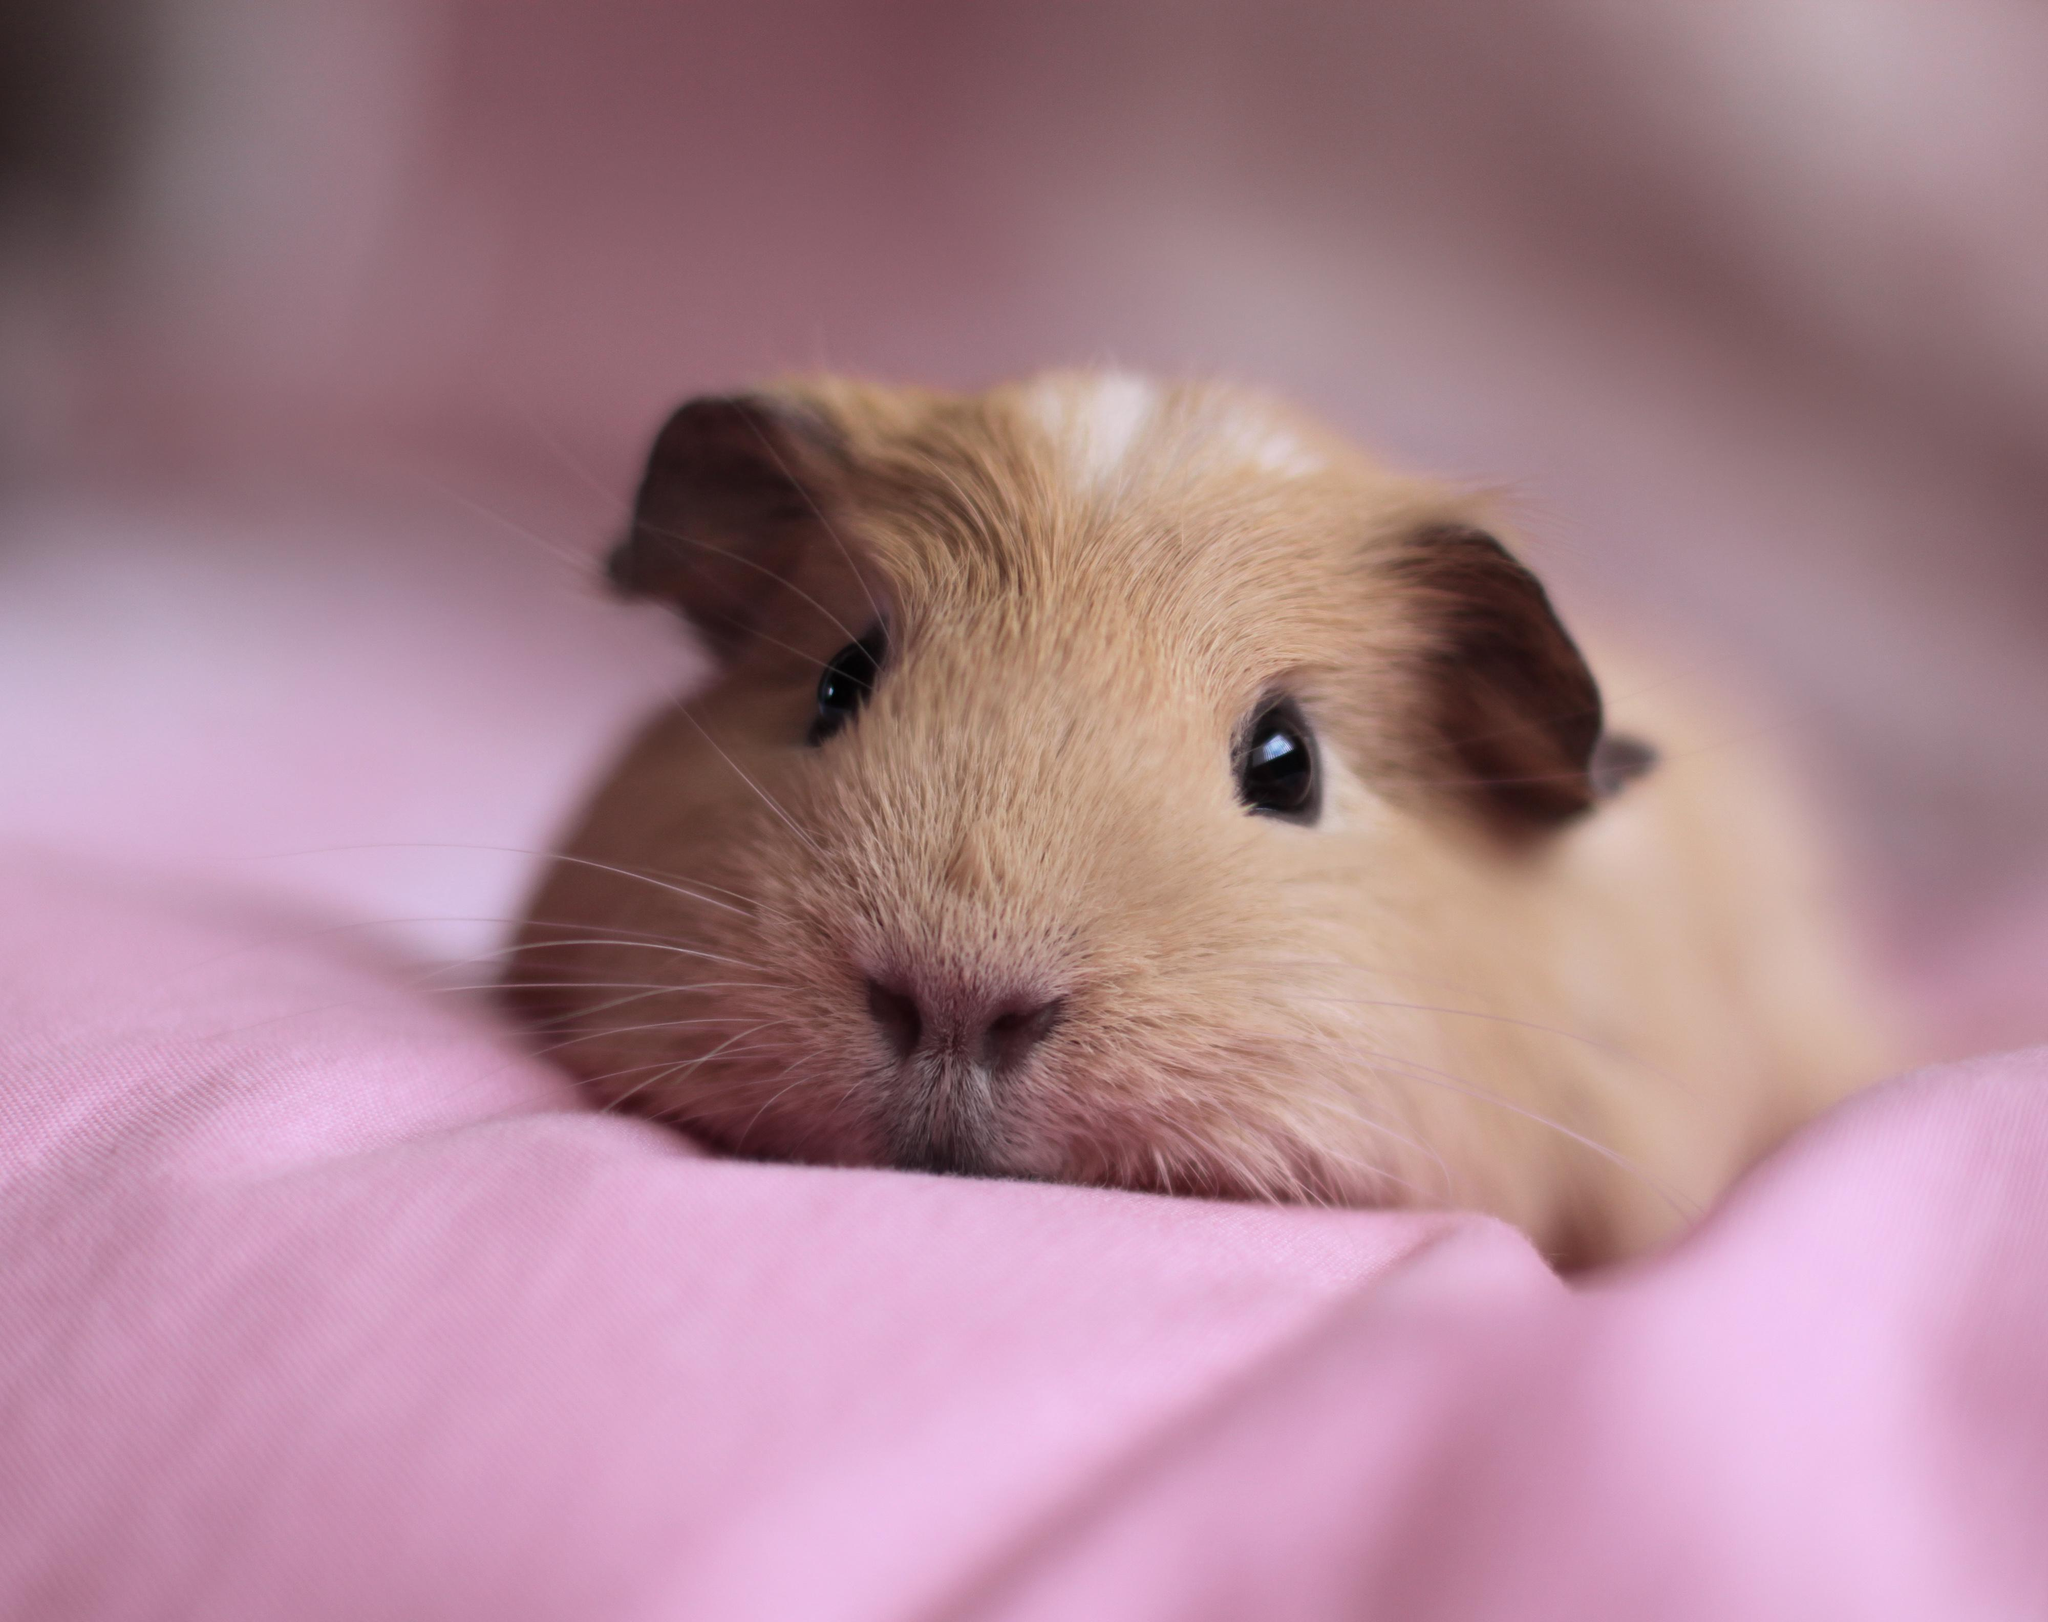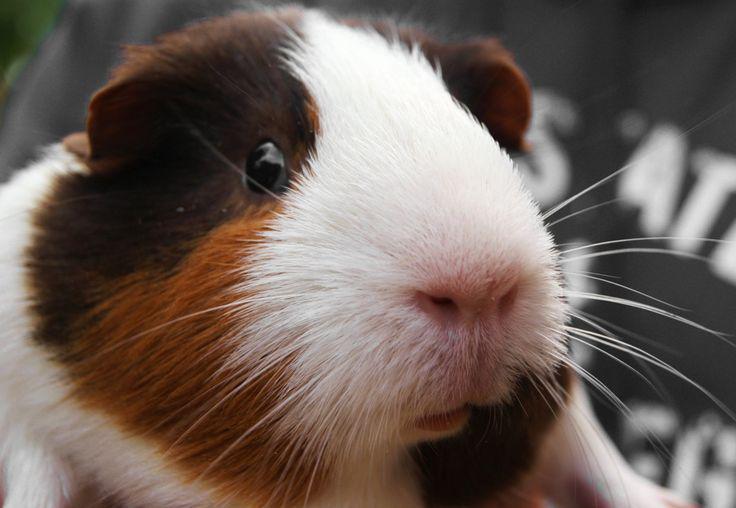The first image is the image on the left, the second image is the image on the right. Examine the images to the left and right. Is the description "One of the images shows a guinea pig with daisies on its head." accurate? Answer yes or no. No. 